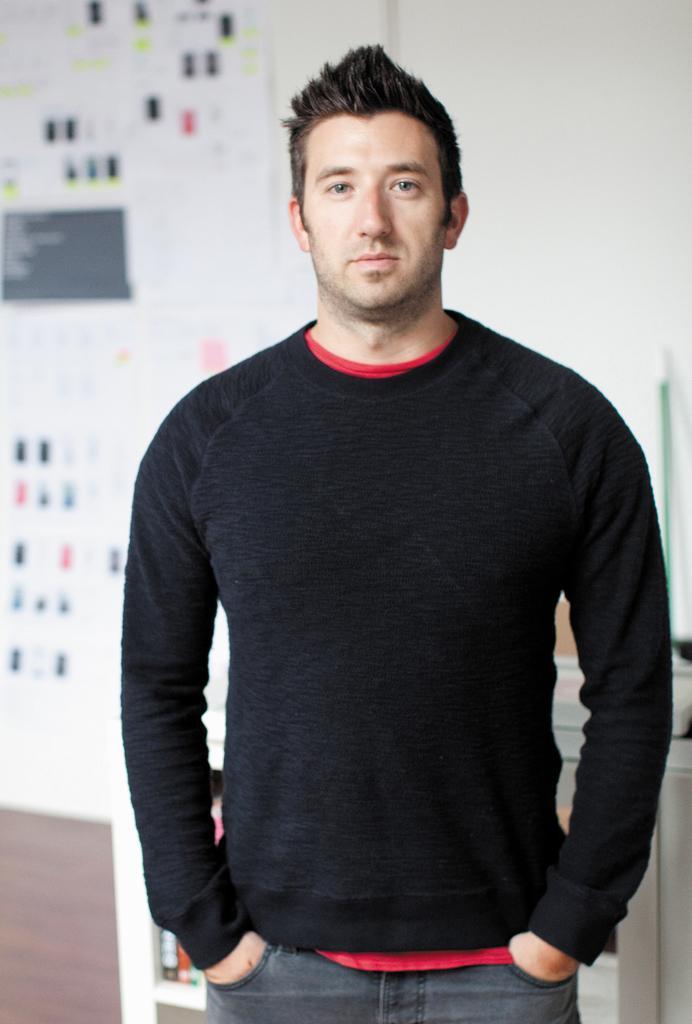How would you summarize this image in a sentence or two? In the middle of the image we can see a man, he is standing, behind him we can see few posts on the wall. 